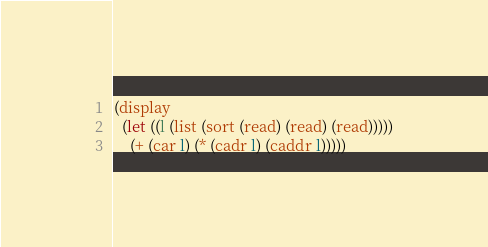Convert code to text. <code><loc_0><loc_0><loc_500><loc_500><_Scheme_>(display
  (let ((l (list (sort (read) (read) (read)))))
    (+ (car l) (* (cadr l) (caddr l)))))
</code> 